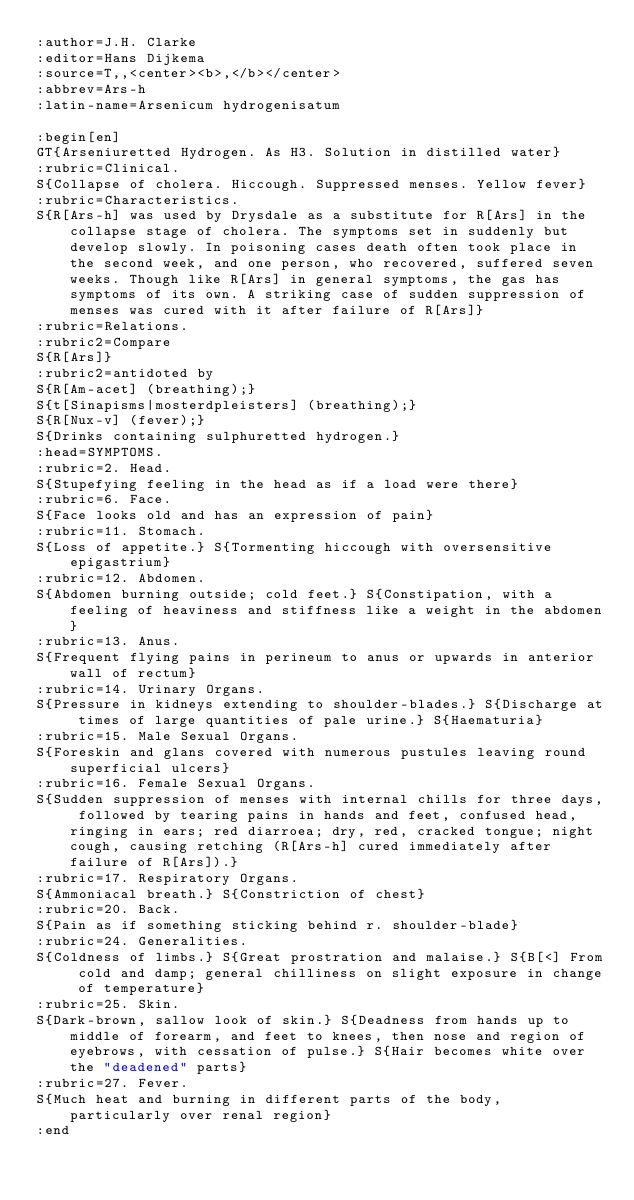Convert code to text. <code><loc_0><loc_0><loc_500><loc_500><_ObjectiveC_>:author=J.H. Clarke
:editor=Hans Dijkema
:source=T,,<center><b>,</b></center>
:abbrev=Ars-h
:latin-name=Arsenicum hydrogenisatum

:begin[en]
GT{Arseniuretted Hydrogen. As H3. Solution in distilled water}
:rubric=Clinical.
S{Collapse of cholera. Hiccough. Suppressed menses. Yellow fever}
:rubric=Characteristics.
S{R[Ars-h] was used by Drysdale as a substitute for R[Ars] in the collapse stage of cholera. The symptoms set in suddenly but develop slowly. In poisoning cases death often took place in the second week, and one person, who recovered, suffered seven weeks. Though like R[Ars] in general symptoms, the gas has symptoms of its own. A striking case of sudden suppression of menses was cured with it after failure of R[Ars]}
:rubric=Relations.
:rubric2=Compare
S{R[Ars]}
:rubric2=antidoted by 
S{R[Am-acet] (breathing);} 
S{t[Sinapisms|mosterdpleisters] (breathing);}
S{R[Nux-v] (fever);}
S{Drinks containing sulphuretted hydrogen.}
:head=SYMPTOMS.
:rubric=2. Head.
S{Stupefying feeling in the head as if a load were there}
:rubric=6. Face.
S{Face looks old and has an expression of pain}
:rubric=11. Stomach.
S{Loss of appetite.} S{Tormenting hiccough with oversensitive epigastrium}
:rubric=12. Abdomen.
S{Abdomen burning outside; cold feet.} S{Constipation, with a feeling of heaviness and stiffness like a weight in the abdomen}
:rubric=13. Anus.
S{Frequent flying pains in perineum to anus or upwards in anterior wall of rectum}
:rubric=14. Urinary Organs.
S{Pressure in kidneys extending to shoulder-blades.} S{Discharge at times of large quantities of pale urine.} S{Haematuria}
:rubric=15. Male Sexual Organs.
S{Foreskin and glans covered with numerous pustules leaving round superficial ulcers}
:rubric=16. Female Sexual Organs.
S{Sudden suppression of menses with internal chills for three days, followed by tearing pains in hands and feet, confused head, ringing in ears; red diarroea; dry, red, cracked tongue; night cough, causing retching (R[Ars-h] cured immediately after failure of R[Ars]).}
:rubric=17. Respiratory Organs.
S{Ammoniacal breath.} S{Constriction of chest}
:rubric=20. Back.
S{Pain as if something sticking behind r. shoulder-blade}
:rubric=24. Generalities.
S{Coldness of limbs.} S{Great prostration and malaise.} S{B[<] From cold and damp; general chilliness on slight exposure in change of temperature}
:rubric=25. Skin.
S{Dark-brown, sallow look of skin.} S{Deadness from hands up to middle of forearm, and feet to knees, then nose and region of eyebrows, with cessation of pulse.} S{Hair becomes white over the "deadened" parts}
:rubric=27. Fever.
S{Much heat and burning in different parts of the body, particularly over renal region}
:end</code> 